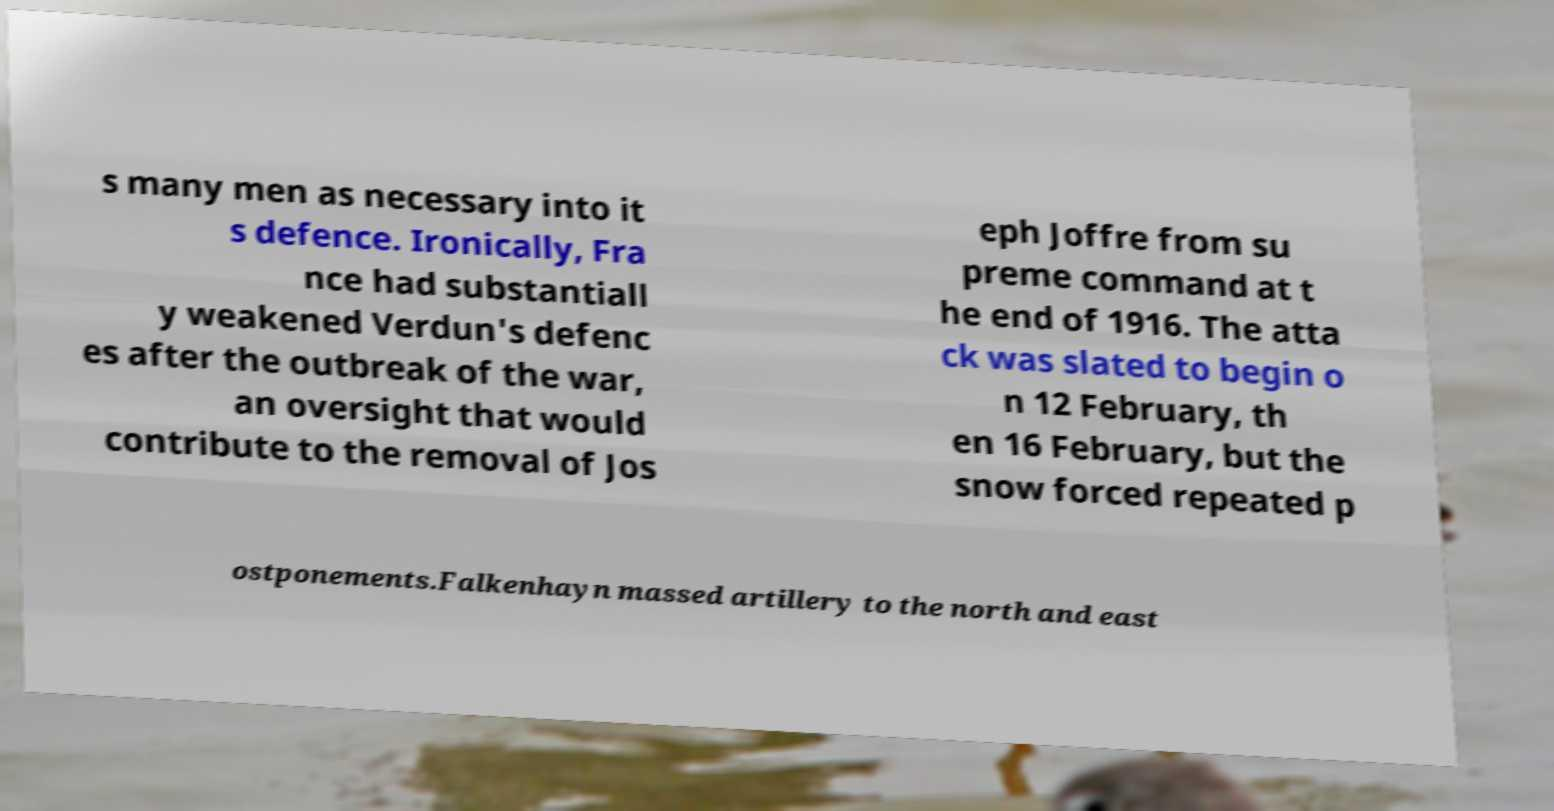Could you extract and type out the text from this image? s many men as necessary into it s defence. Ironically, Fra nce had substantiall y weakened Verdun's defenc es after the outbreak of the war, an oversight that would contribute to the removal of Jos eph Joffre from su preme command at t he end of 1916. The atta ck was slated to begin o n 12 February, th en 16 February, but the snow forced repeated p ostponements.Falkenhayn massed artillery to the north and east 